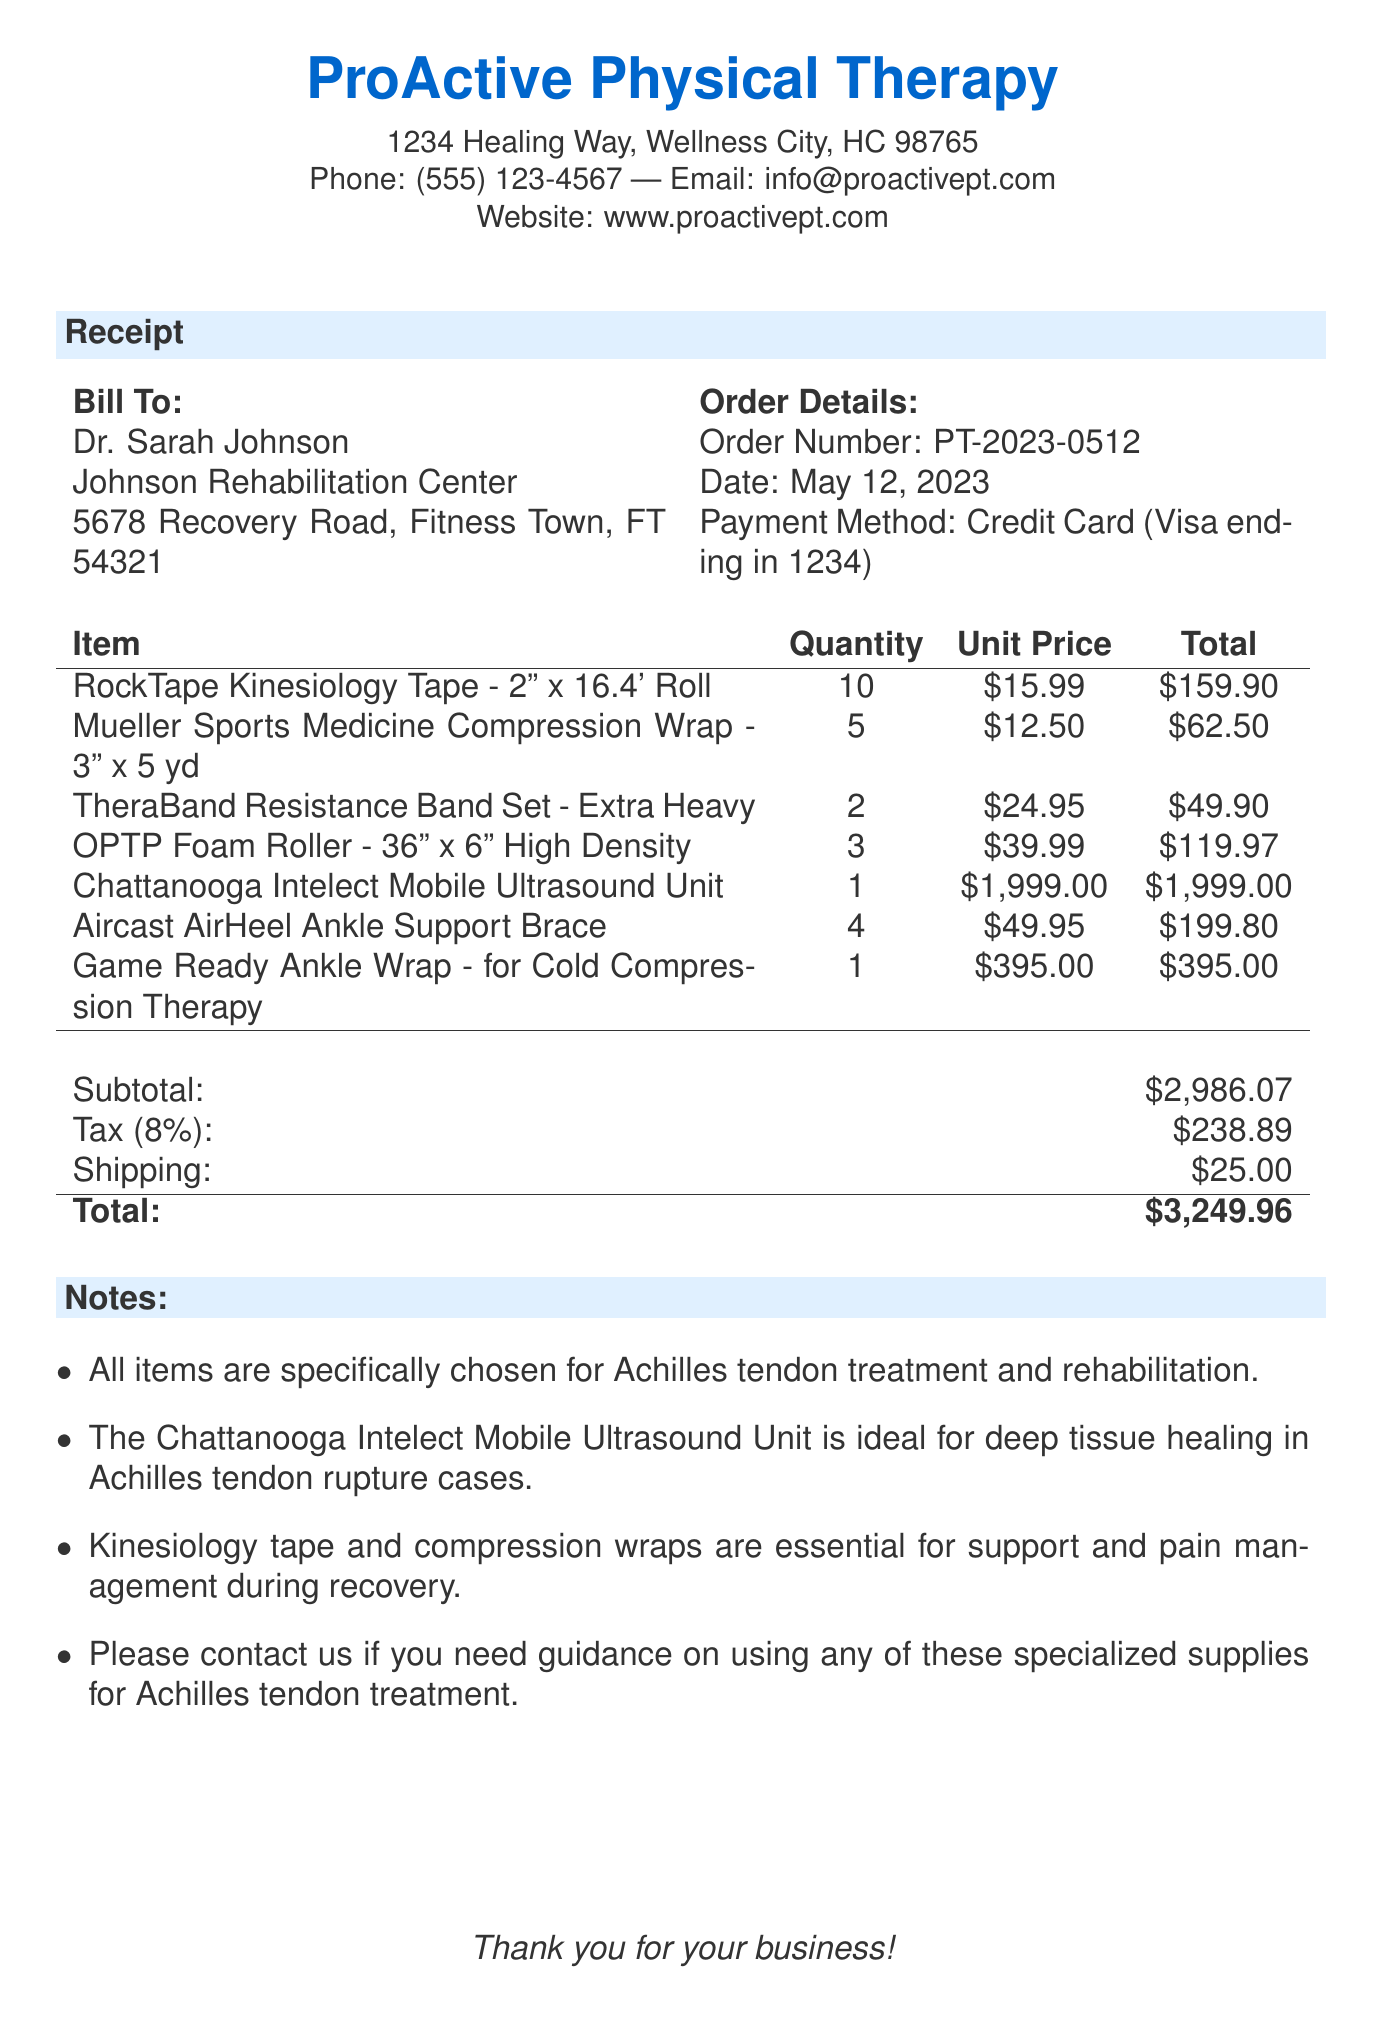What is the name of the business? The name of the business is mentioned at the top of the receipt, which is ProActive Physical Therapy.
Answer: ProActive Physical Therapy What is the order number? The order number is stated in the order details section of the receipt, which is PT-2023-0512.
Answer: PT-2023-0512 What is the date of the order? The date of the order can be found in the order details, which indicates May 12, 2023.
Answer: May 12, 2023 How many RockTape Kinesiology Tape rolls were purchased? The quantity of RockTape Kinesiology Tape rolls is specified in the items section, which shows 10 units were purchased.
Answer: 10 What is the total amount for the Chattanooga Intelect Mobile Ultrasound Unit? The total amount for the ultrasound unit is provided in the items section as $1,999.00.
Answer: $1,999.00 What is the subtotal before tax and shipping? The subtotal before tax and shipping is mentioned in the totals section, which is $2,986.07.
Answer: $2,986.07 What percentage tax was applied? The tax rate is indicated in the totals section as 8%.
Answer: 8% Which item is specifically noted for deep tissue healing in Achilles tendon rupture cases? The item noted for deep tissue healing is mentioned in the notes section, specifically the Chattanooga Intelect Mobile Ultrasound Unit.
Answer: Chattanooga Intelect Mobile Ultrasound Unit What is the shipping cost for the order? The shipping cost is listed in the totals section, which is $25.00.
Answer: $25.00 